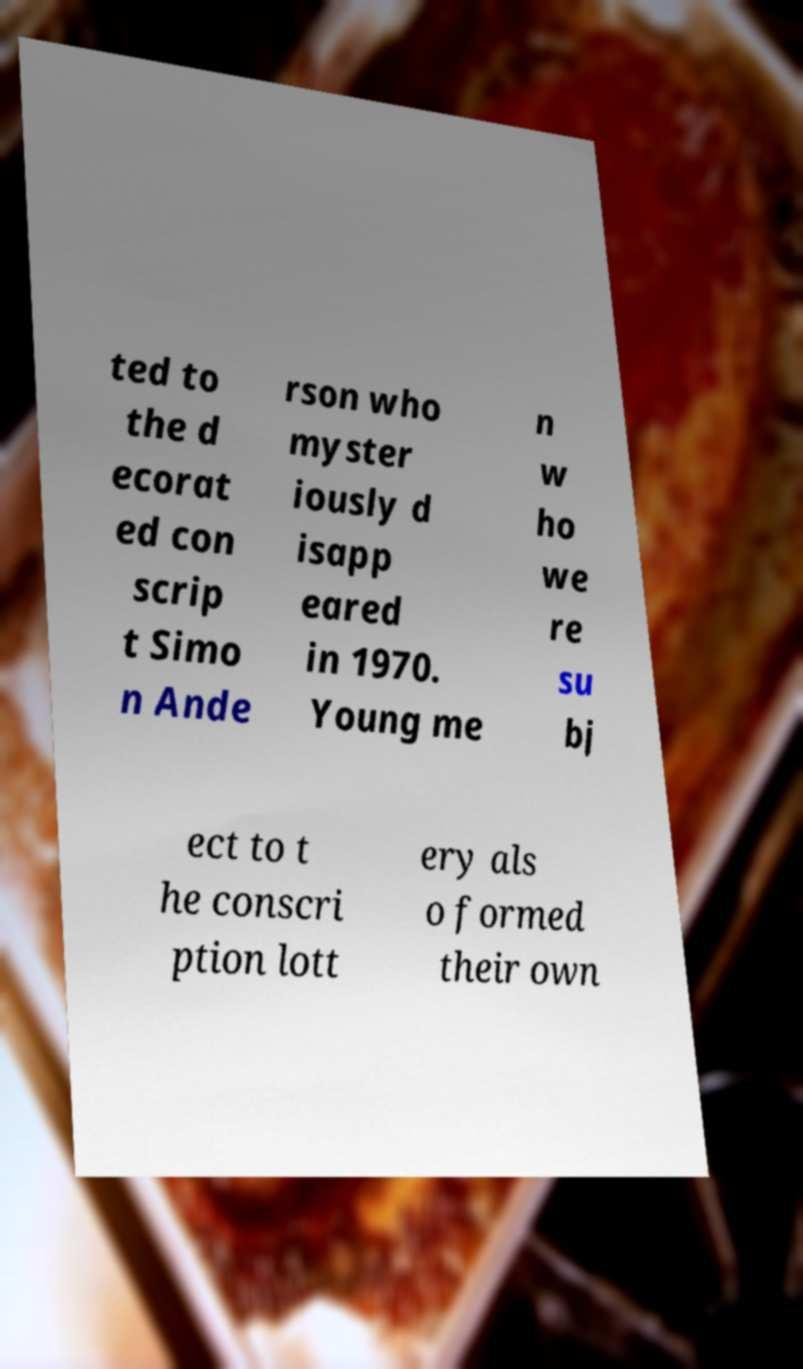Could you extract and type out the text from this image? ted to the d ecorat ed con scrip t Simo n Ande rson who myster iously d isapp eared in 1970. Young me n w ho we re su bj ect to t he conscri ption lott ery als o formed their own 